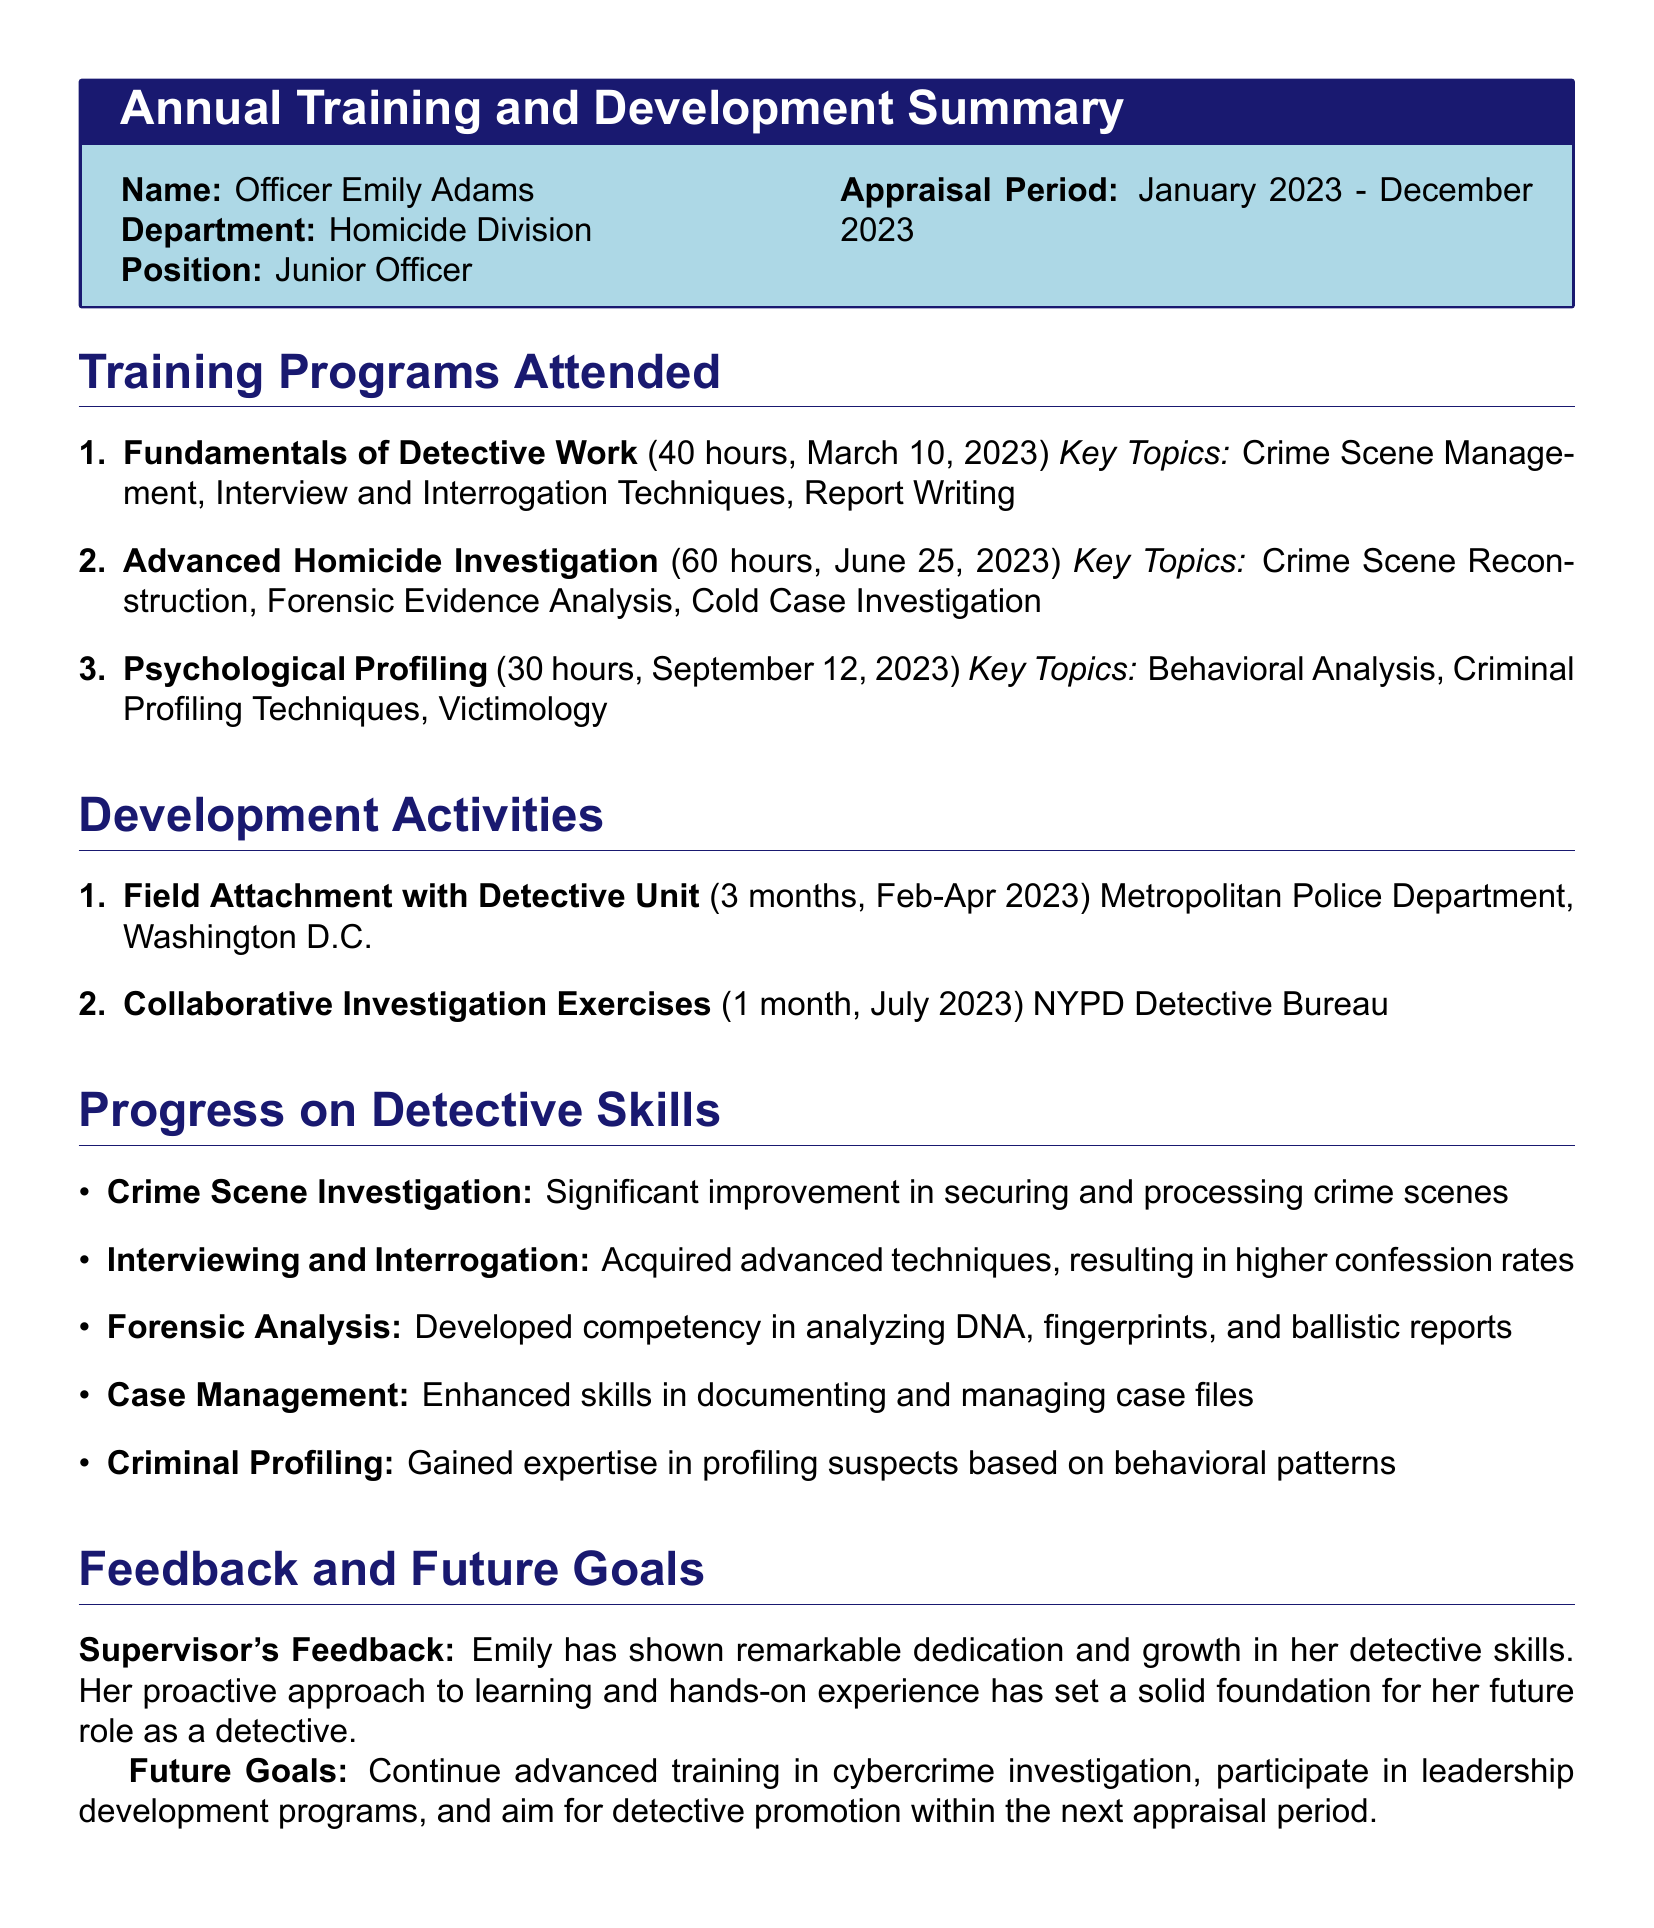what is the name of the officer? The officer's name is listed at the top of the document in the personal information section.
Answer: Officer Emily Adams what is the department of the officer? The department information can be found near the officer's name.
Answer: Homicide Division how many training programs did the officer attend? The training programs attended are enumerated in the section titled "Training Programs Attended."
Answer: 3 what is the duration of the field attachment activity? The duration is specified in the "Development Activities" section.
Answer: 3 months when did the officer complete the "Advanced Homicide Investigation" training? The date is mentioned alongside the training program title.
Answer: June 25, 2023 what skill showed significant improvement? The skills section lists specific areas of improvement.
Answer: Crime Scene Investigation what is one future goal of the officer? Future goals are outlined in the "Future Goals" section, providing insight into the officer's aspirations.
Answer: Continue advanced training in cybercrime investigation who provided feedback on the officer's performance? Feedback is given by the officer's supervisor in the designated section of the document.
Answer: Supervisor how many hours did the "Psychological Profiling" training last? The duration is detailed next to the training program in the list.
Answer: 30 hours what advanced skill did the officer develop related to forensic analysis? The skill gained is specified in the "Progress on Detective Skills" section.
Answer: Analyzing DNA, fingerprints, and ballistic reports 